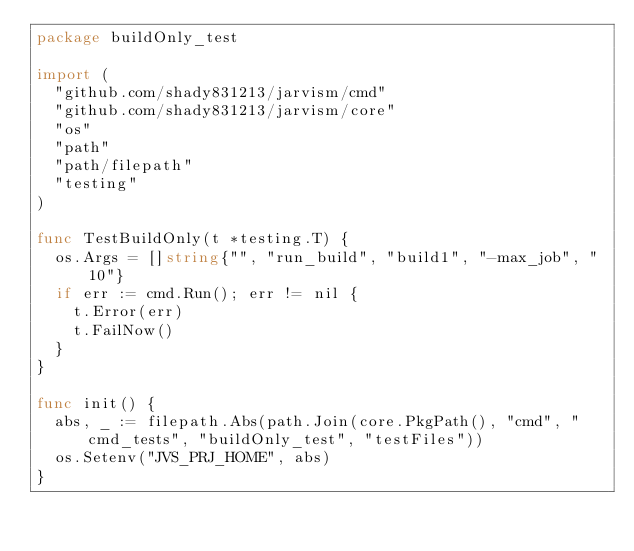Convert code to text. <code><loc_0><loc_0><loc_500><loc_500><_Go_>package buildOnly_test

import (
	"github.com/shady831213/jarvism/cmd"
	"github.com/shady831213/jarvism/core"
	"os"
	"path"
	"path/filepath"
	"testing"
)

func TestBuildOnly(t *testing.T) {
	os.Args = []string{"", "run_build", "build1", "-max_job", "10"}
	if err := cmd.Run(); err != nil {
		t.Error(err)
		t.FailNow()
	}
}

func init() {
	abs, _ := filepath.Abs(path.Join(core.PkgPath(), "cmd", "cmd_tests", "buildOnly_test", "testFiles"))
	os.Setenv("JVS_PRJ_HOME", abs)
}
</code> 